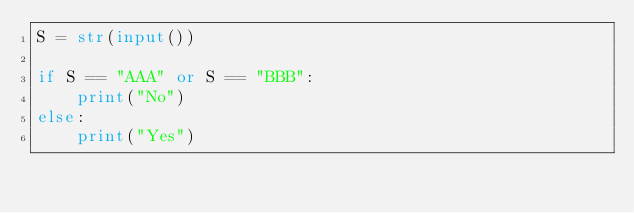<code> <loc_0><loc_0><loc_500><loc_500><_Python_>S = str(input())

if S == "AAA" or S == "BBB":
    print("No")
else:
    print("Yes")</code> 